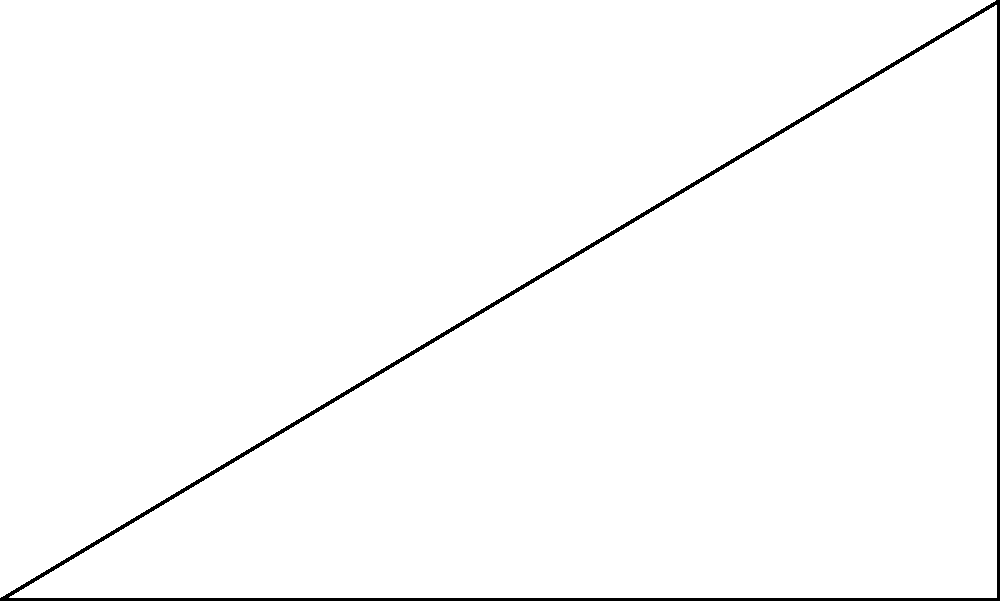During a crucial game against rival team Florida State, a Valdosta State batter swings his bat. The tip of the bat travels in an arc, with the handle acting as the center of rotation. If the bat is 5 feet long and the highest point of the swing is 3 feet above the horizontal, what is the angle $\theta$ of the batter's swing in degrees? Let's approach this step-by-step using trigonometry:

1) The scenario forms a right triangle, where:
   - The hypotenuse is the bat length (5 feet)
   - The opposite side is the height of the swing (3 feet)
   - The angle we're looking for is $\theta$

2) In a right triangle, we can use the sine function to find the angle:

   $\sin(\theta) = \frac{\text{opposite}}{\text{hypotenuse}} = \frac{3}{5}$

3) To find $\theta$, we need to take the inverse sine (arcsin) of both sides:

   $\theta = \arcsin(\frac{3}{5})$

4) Using a calculator or trigonometric tables:

   $\theta \approx 36.87$ degrees

5) Rounding to the nearest degree:

   $\theta \approx 37$ degrees

This angle represents how far the bat has traveled from its starting horizontal position to its highest point in the swing.
Answer: $37^\circ$ 